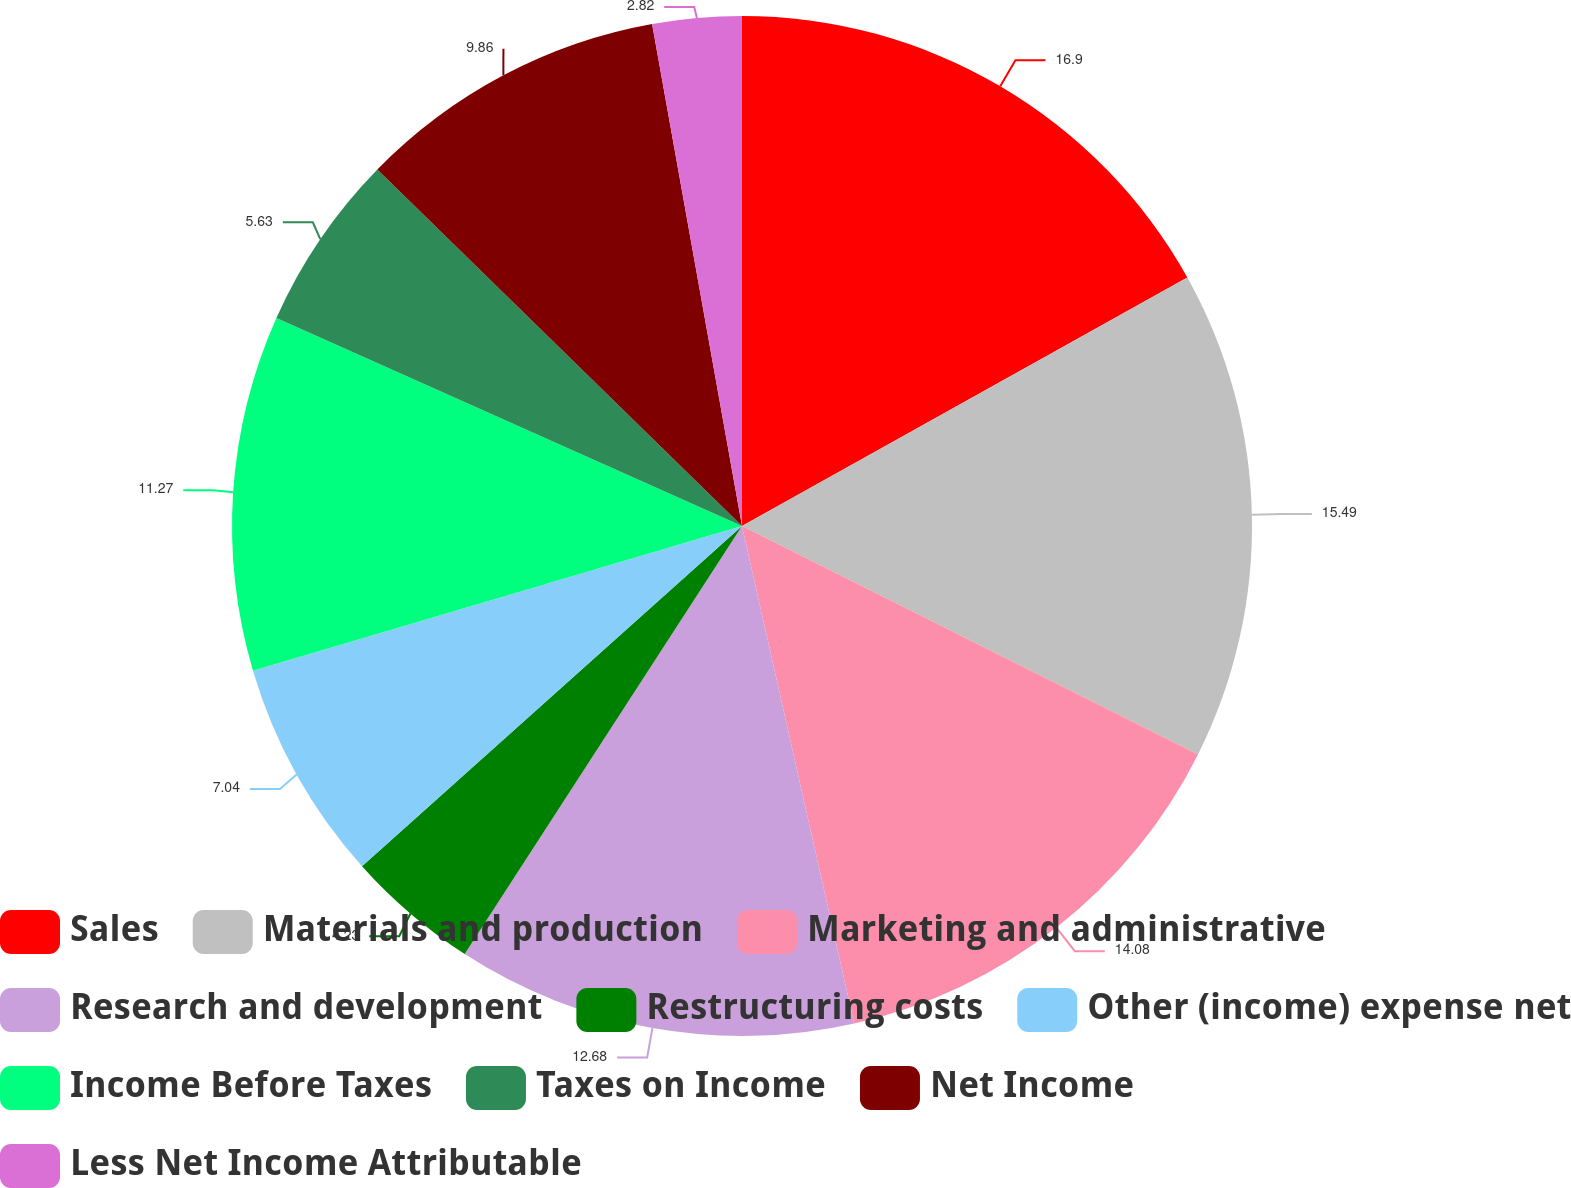<chart> <loc_0><loc_0><loc_500><loc_500><pie_chart><fcel>Sales<fcel>Materials and production<fcel>Marketing and administrative<fcel>Research and development<fcel>Restructuring costs<fcel>Other (income) expense net<fcel>Income Before Taxes<fcel>Taxes on Income<fcel>Net Income<fcel>Less Net Income Attributable<nl><fcel>16.9%<fcel>15.49%<fcel>14.08%<fcel>12.68%<fcel>4.23%<fcel>7.04%<fcel>11.27%<fcel>5.63%<fcel>9.86%<fcel>2.82%<nl></chart> 